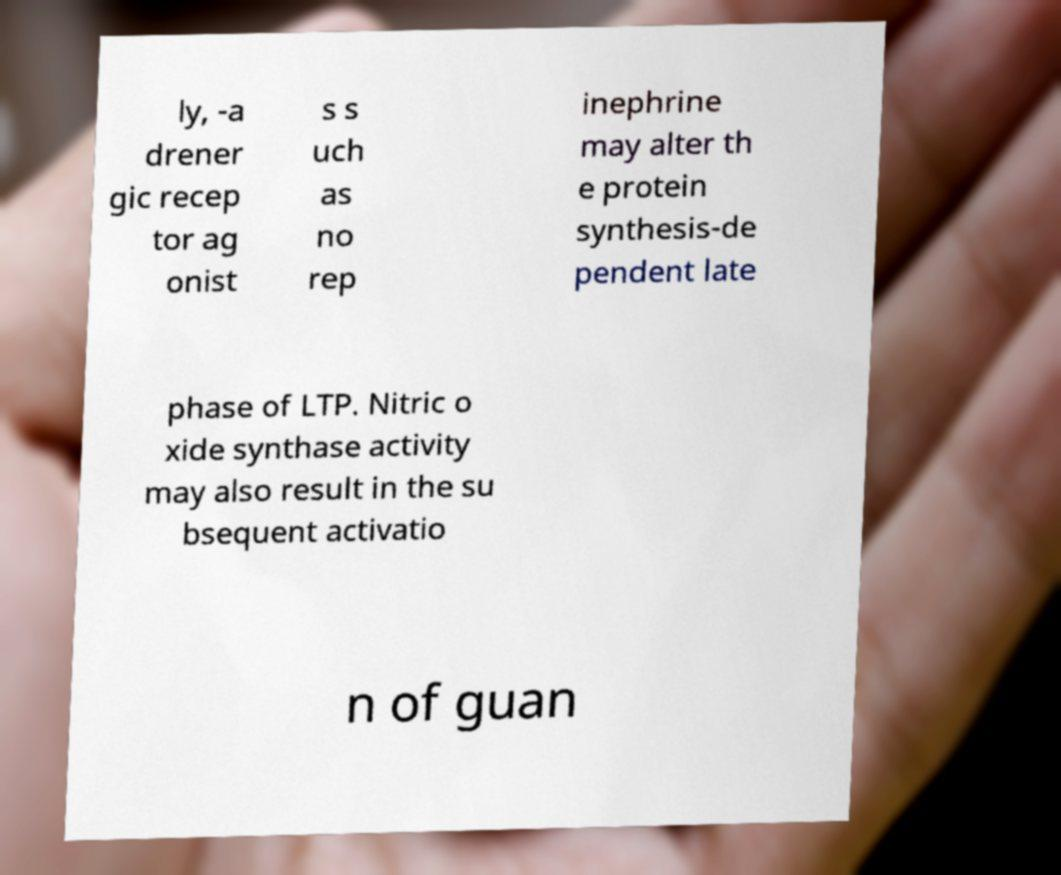Can you read and provide the text displayed in the image?This photo seems to have some interesting text. Can you extract and type it out for me? ly, -a drener gic recep tor ag onist s s uch as no rep inephrine may alter th e protein synthesis-de pendent late phase of LTP. Nitric o xide synthase activity may also result in the su bsequent activatio n of guan 